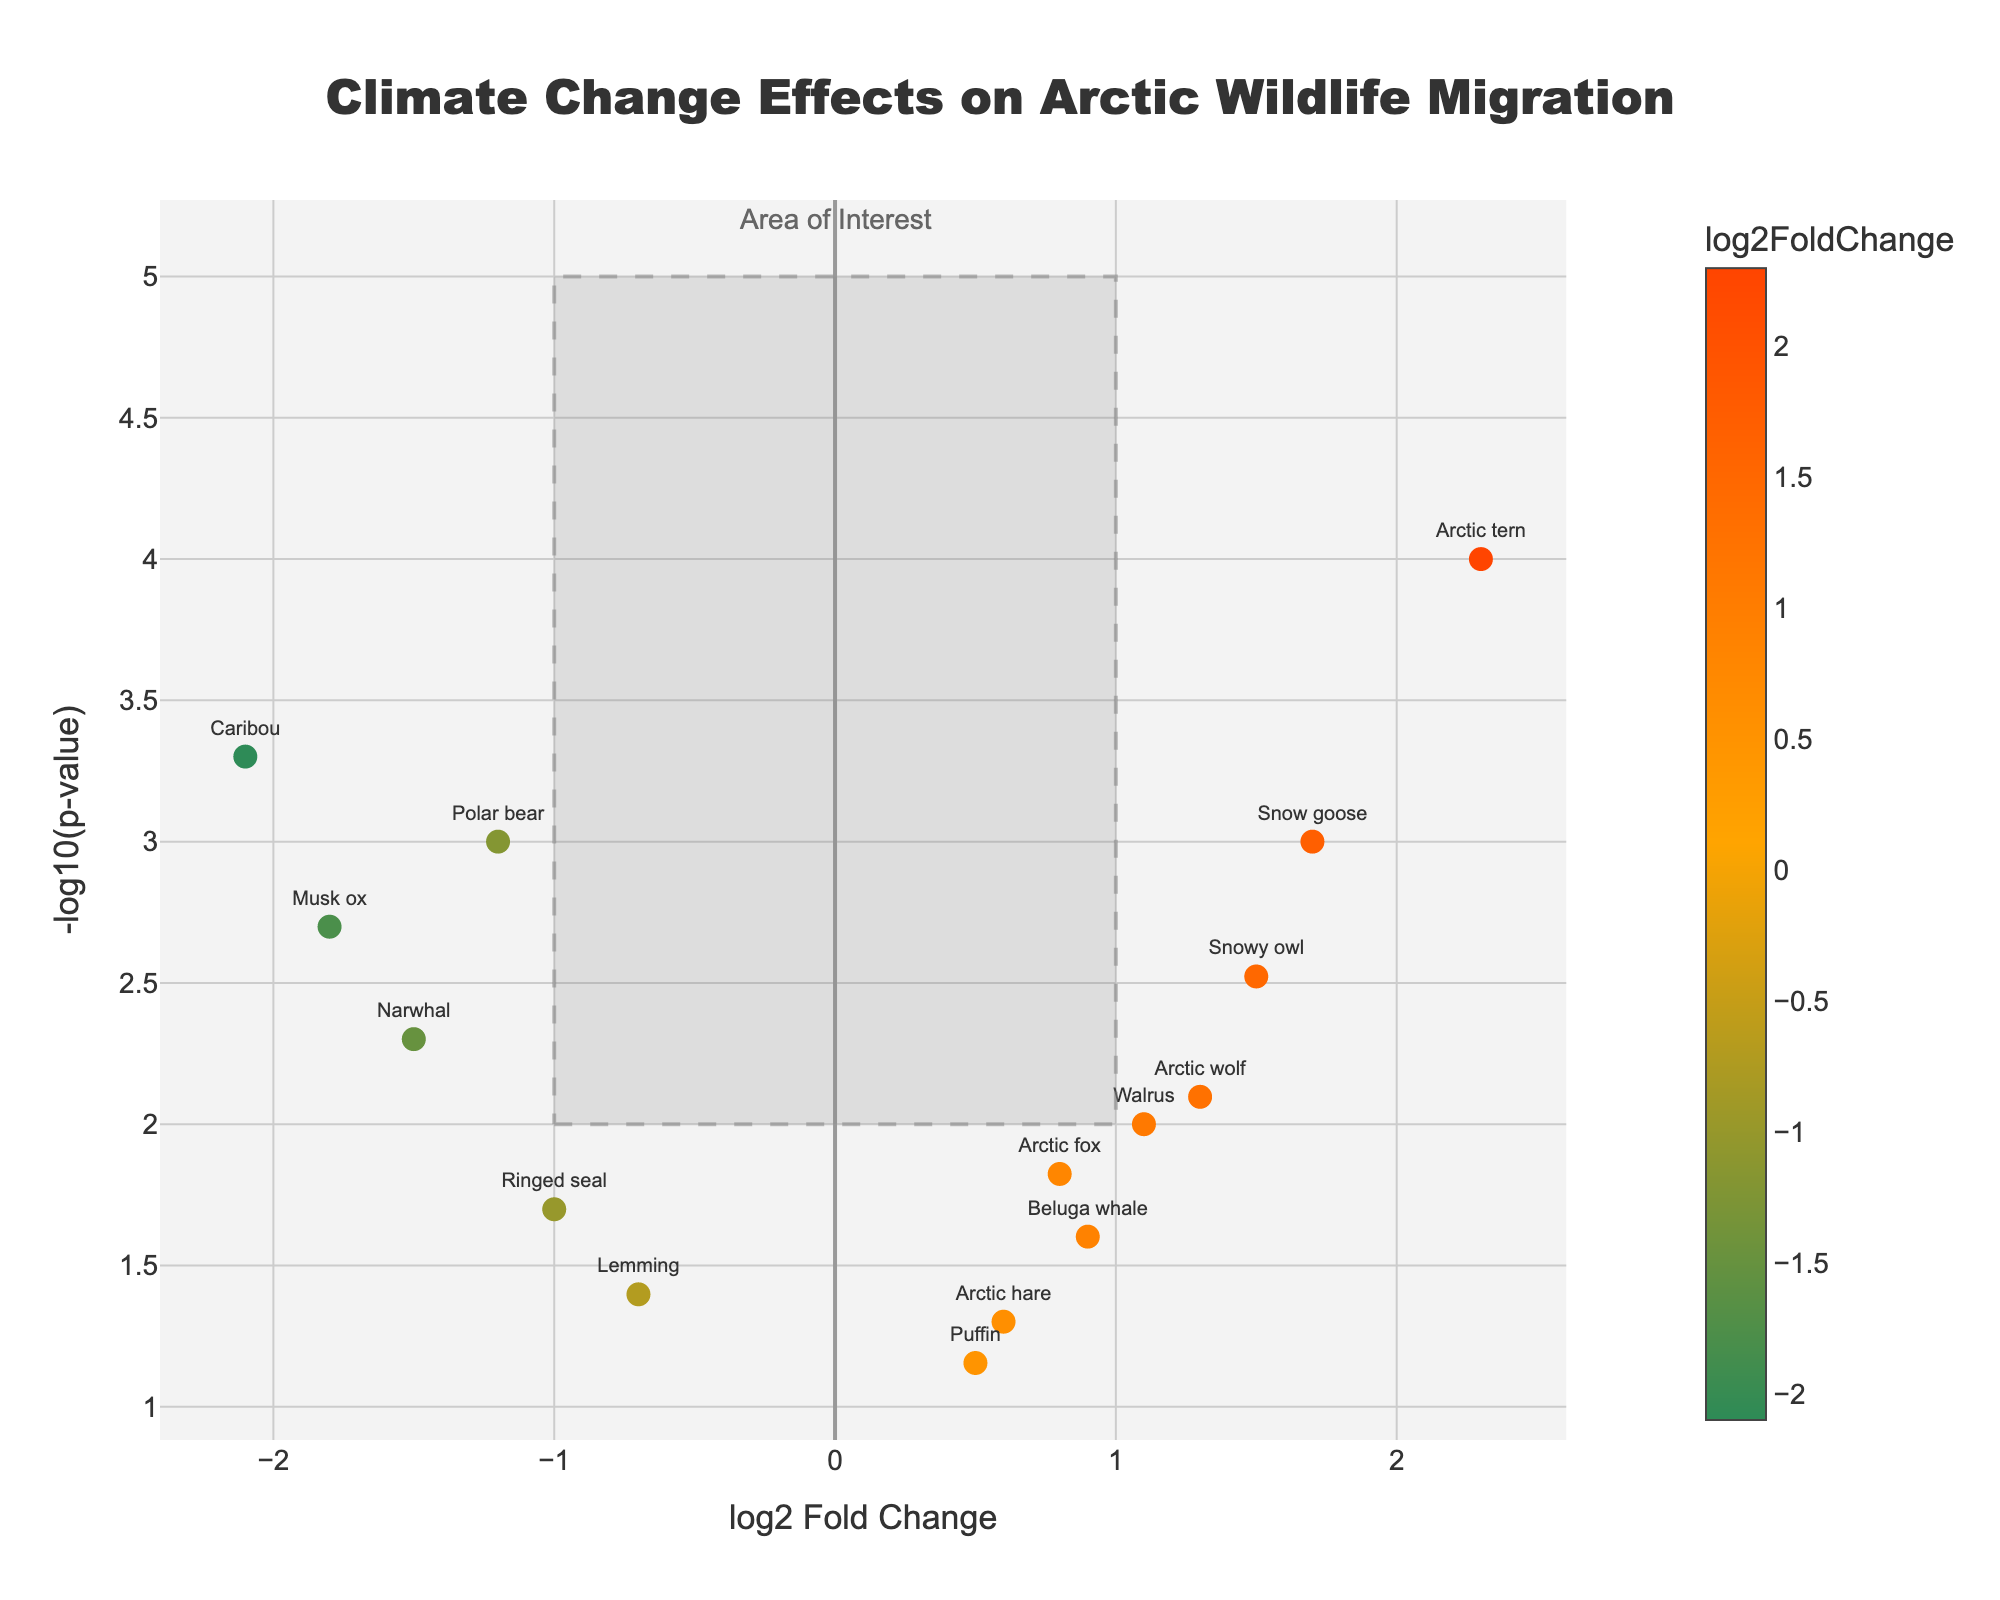What is the title of the plot? The title is located at the top center of the plot. It reads "Climate Change Effects on Arctic Wildlife Migration".
Answer: Climate Change Effects on Arctic Wildlife Migration What does the x-axis represent? The x-axis label is "log2 Fold Change", indicating the representation of log2 fold change values on the x-axis.
Answer: log2 Fold Change Which species shows the highest log2 fold change? The data point with the highest log2 fold change has a value of 2.3, corresponding to the "Arctic tern".
Answer: Arctic tern How many species have a log2 fold change greater than 1? By inspecting the data points on the x-axis, five species have log2 fold changes greater than 1: Snowy owl (1.5), Walrus (1.1), Arctic wolf (1.3), Snow goose (1.7), and Arctic tern (2.3).
Answer: Five species What does the y-axis represent? The y-axis is labeled "-log10(p-value)", which represents the -log10 transformed p-values on the y-axis.
Answer: -log10(p-value) Between Polar bear and Caribou, which species has a larger magnitude of log2 fold change? The absolute log2 fold changes for Polar bear and Caribou are 1.2 and 2.1, respectively. Since Caribou has a higher absolute value, it has the larger magnitude.
Answer: Caribou What is the log2 fold change value for the species with the smallest p-value? By looking for the smallest p-value on the plot, Arctic tern has the smallest p-value of 0.0001, with a corresponding log2 fold change of 2.3.
Answer: 2.3 How many species fall within the "Area of Interest"? Counting the data points inside the highlighted rectangular region (-1 to 1 on x-axis and 2 to 5 on y-axis), we find seven species: Arctic hare, Beluga whale, Lemming, Puffin, Ringed seal, Narwhal, and Polar bear.
Answer: Seven species Which species have a negative log2 fold change and a p-value less than 0.01? By inspecting the points below 0 on the x-axis and greater than 2 on the y-axis, the species meeting these criteria are Polar bear, Caribou, Musk ox, and Narwhal.
Answer: Polar bear, Caribou, Musk ox, Narwhal Do any species have a p-value exactly equal to 0.025? Yes, Beluga whale has a p-value exactly equal to 0.025, discernible from the hover text or data point position on the plot.
Answer: Beluga whale 